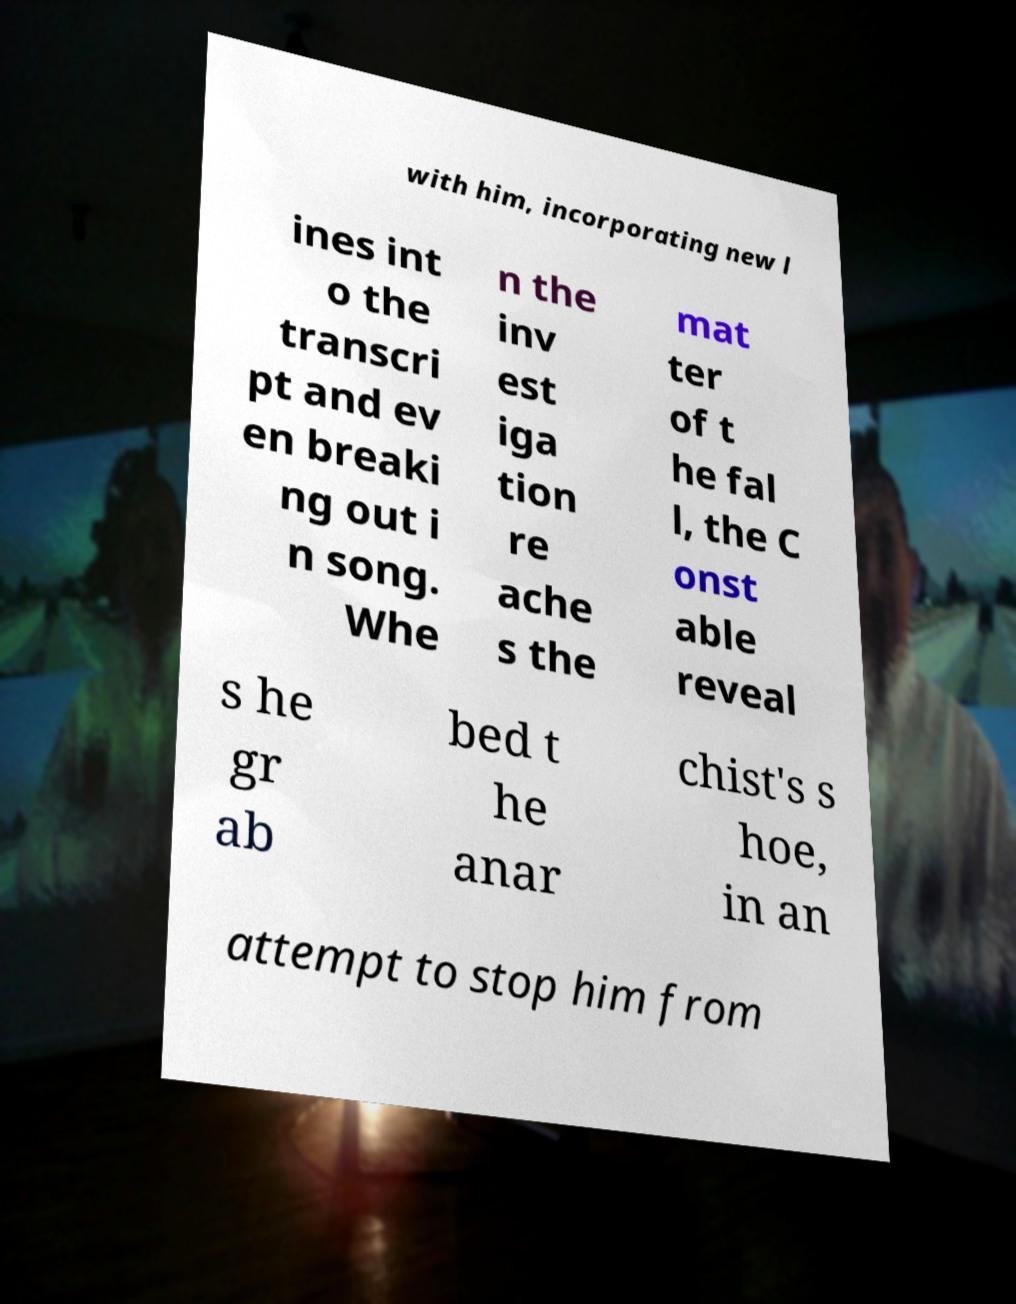Could you extract and type out the text from this image? with him, incorporating new l ines int o the transcri pt and ev en breaki ng out i n song. Whe n the inv est iga tion re ache s the mat ter of t he fal l, the C onst able reveal s he gr ab bed t he anar chist's s hoe, in an attempt to stop him from 